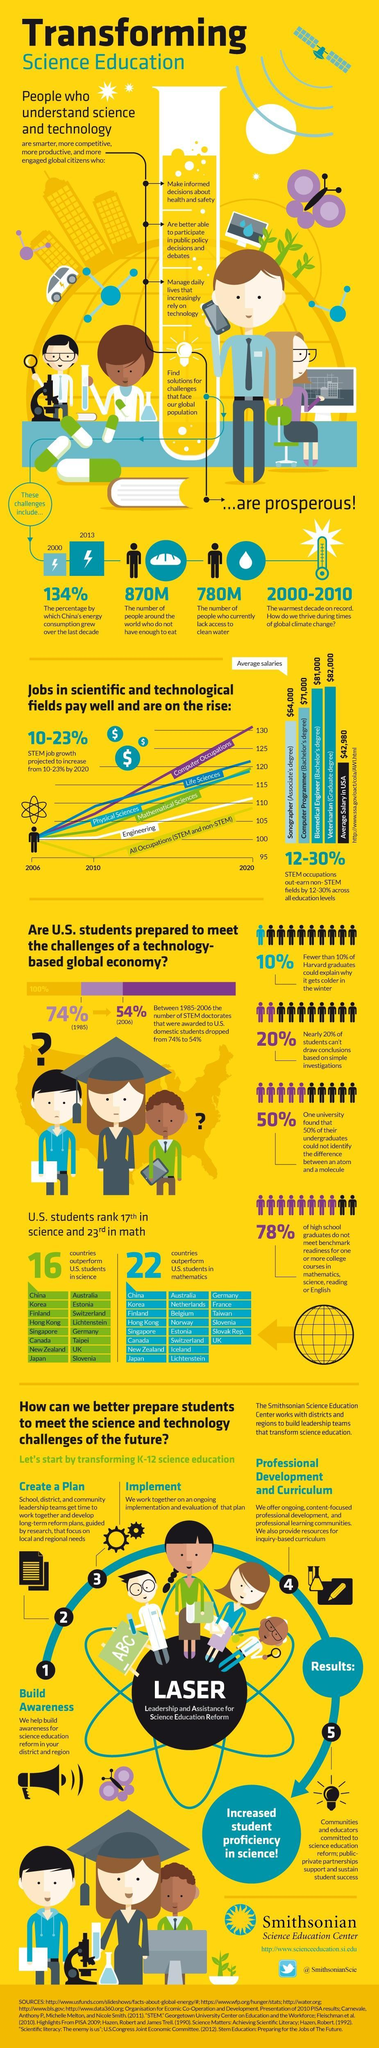What is the position of US students in mathematics when compared to other countries
Answer the question with a short phrase. 23 How much higher is the average salary of a sonographer when compared to the average salary in USA in dollars 22000 What is the average salary for a computer programmer (Bachelor's degree) $71,000 How many people do not have access to clean water 780M Has there been a rise or a fall on the STEM doctorates from 1985-2006 fall What has been the warmest decade 2000-2010 How many people do not enough to ear around the world 870M 